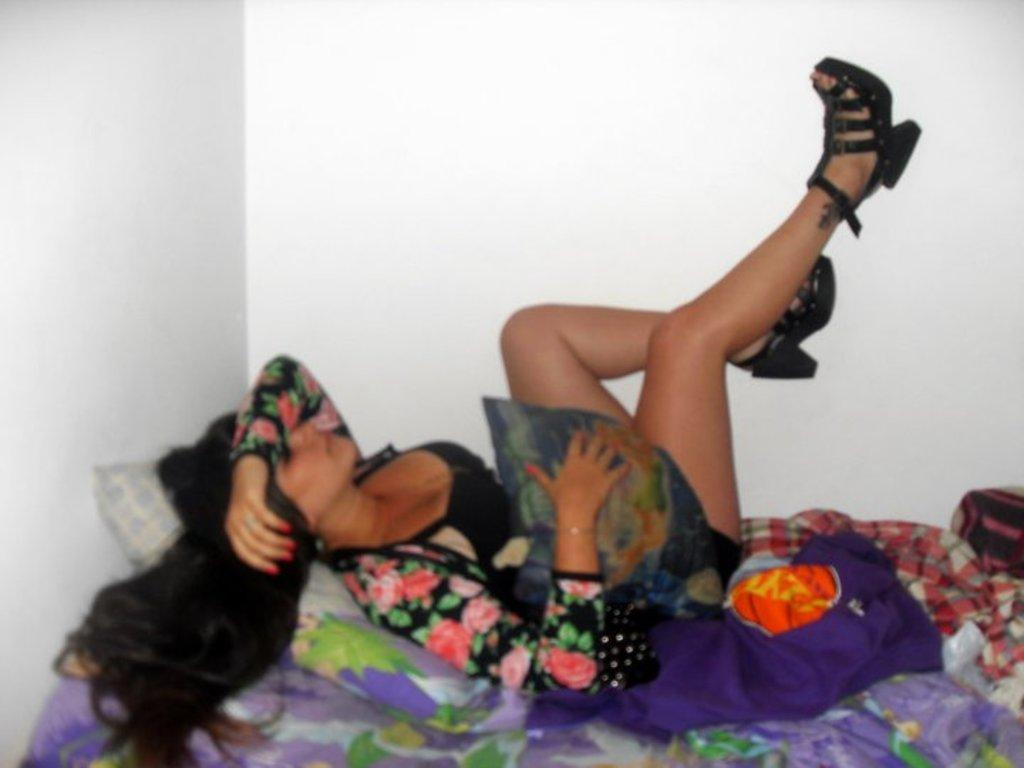Who or what is the main subject in the image? There is a person in the image. What is the person doing or where are they located? The person is on a bed. Can you describe the bed's position in relation to other objects or structures? The bed is beside a wall. What is the person wearing in the image? The person is wearing clothes and footwear. What type of detail can be seen in the person's footwear in the image? There is no specific detail mentioned about the person's footwear in the image. 